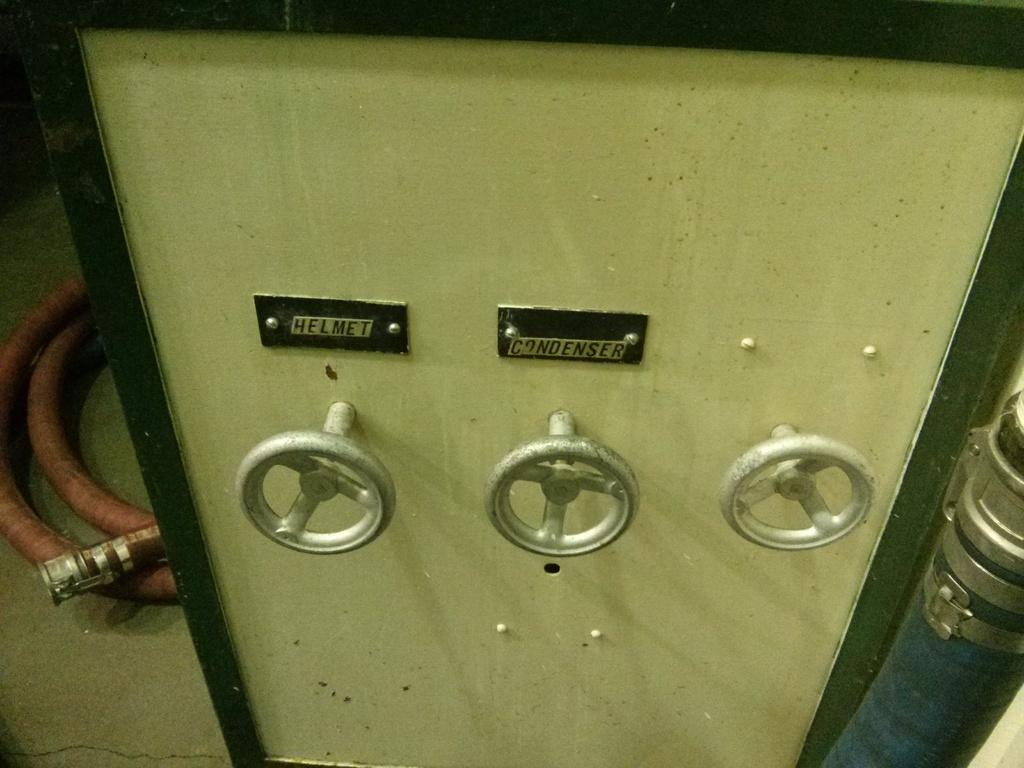What is the main object in the image? There is a pipe in the image. What other objects can be seen in the image? There are metal wheels on a cupboard in the image. Can you describe the setting of the image? The image may have been taken in a hall. What type of road can be seen in the image? There is no road present in the image; it features a pipe and a cupboard with metal wheels. How many ears are visible in the image? There are no ears visible in the image. 